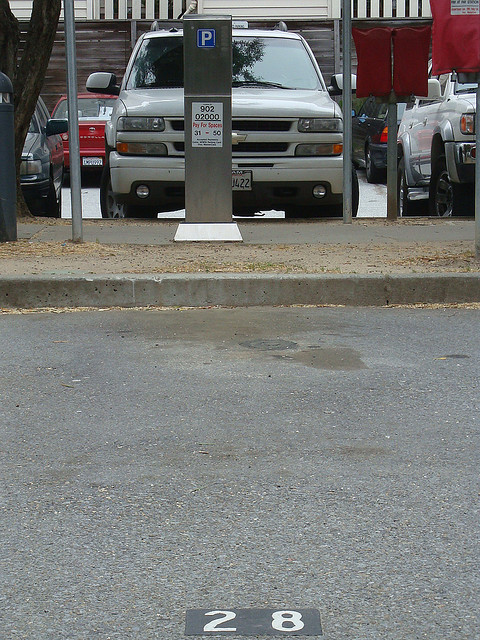What kind of technological improvements can be introduced to make parking easier? Advancements in technology can greatly improve the parking experience. Implementing smart parking systems using sensors and IoT devices can provide real-time information about available parking spots. Mobile apps for parking reservations and mobile payments can streamline the process further. Additionally, automated parking garages and autonomous vehicle technology could optimize space utilization and reduce the time spent searching for parking spots. What are the potential drawbacks of these technologies? While technological improvements can enhance convenience, there are potential drawbacks. The initial cost of deploying smart infrastructure can be high, and there might be a learning curve for users unfamiliar with such technology. Additionally, issues related to data privacy and security must be addressed to prevent misuse. Technical malfunctions can also disrupt the intended benefits, emphasizing the need for reliable and user-friendly solutions. 